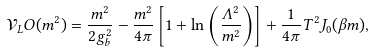Convert formula to latex. <formula><loc_0><loc_0><loc_500><loc_500>\mathcal { V } _ { L } O ( m ^ { 2 } ) = \frac { m ^ { 2 } } { 2 g _ { b } ^ { 2 } } - \frac { m ^ { 2 } } { 4 \pi } \left [ 1 + \ln \left ( \frac { \Lambda ^ { 2 } } { m ^ { 2 } } \right ) \right ] + \frac { 1 } { 4 \pi } T ^ { 2 } J _ { 0 } ( \beta m ) ,</formula> 